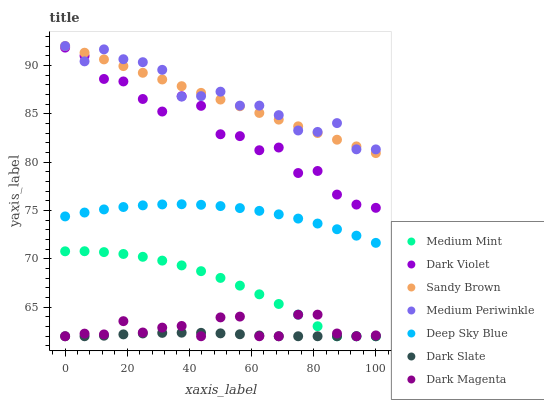Does Dark Slate have the minimum area under the curve?
Answer yes or no. Yes. Does Medium Periwinkle have the maximum area under the curve?
Answer yes or no. Yes. Does Dark Magenta have the minimum area under the curve?
Answer yes or no. No. Does Dark Magenta have the maximum area under the curve?
Answer yes or no. No. Is Sandy Brown the smoothest?
Answer yes or no. Yes. Is Dark Violet the roughest?
Answer yes or no. Yes. Is Dark Magenta the smoothest?
Answer yes or no. No. Is Dark Magenta the roughest?
Answer yes or no. No. Does Medium Mint have the lowest value?
Answer yes or no. Yes. Does Medium Periwinkle have the lowest value?
Answer yes or no. No. Does Sandy Brown have the highest value?
Answer yes or no. Yes. Does Dark Magenta have the highest value?
Answer yes or no. No. Is Dark Magenta less than Medium Periwinkle?
Answer yes or no. Yes. Is Sandy Brown greater than Medium Mint?
Answer yes or no. Yes. Does Sandy Brown intersect Medium Periwinkle?
Answer yes or no. Yes. Is Sandy Brown less than Medium Periwinkle?
Answer yes or no. No. Is Sandy Brown greater than Medium Periwinkle?
Answer yes or no. No. Does Dark Magenta intersect Medium Periwinkle?
Answer yes or no. No. 